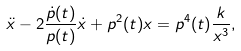<formula> <loc_0><loc_0><loc_500><loc_500>\ddot { x } - 2 \frac { \dot { p } ( t ) } { p ( t ) } \dot { x } + p ^ { 2 } ( t ) x = p ^ { 4 } ( t ) \frac { k } { x ^ { 3 } } ,</formula> 